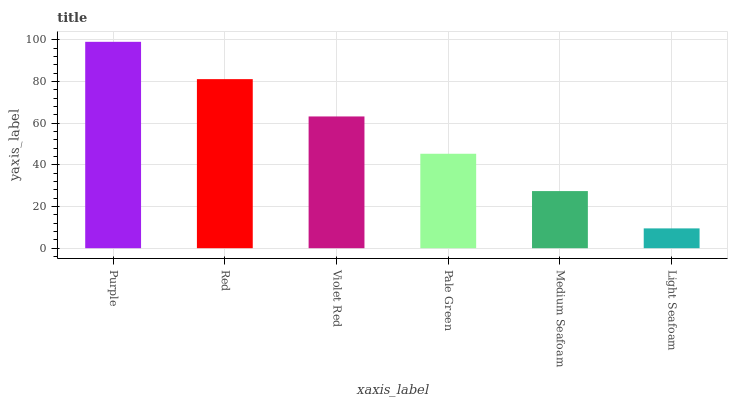Is Light Seafoam the minimum?
Answer yes or no. Yes. Is Purple the maximum?
Answer yes or no. Yes. Is Red the minimum?
Answer yes or no. No. Is Red the maximum?
Answer yes or no. No. Is Purple greater than Red?
Answer yes or no. Yes. Is Red less than Purple?
Answer yes or no. Yes. Is Red greater than Purple?
Answer yes or no. No. Is Purple less than Red?
Answer yes or no. No. Is Violet Red the high median?
Answer yes or no. Yes. Is Pale Green the low median?
Answer yes or no. Yes. Is Purple the high median?
Answer yes or no. No. Is Purple the low median?
Answer yes or no. No. 